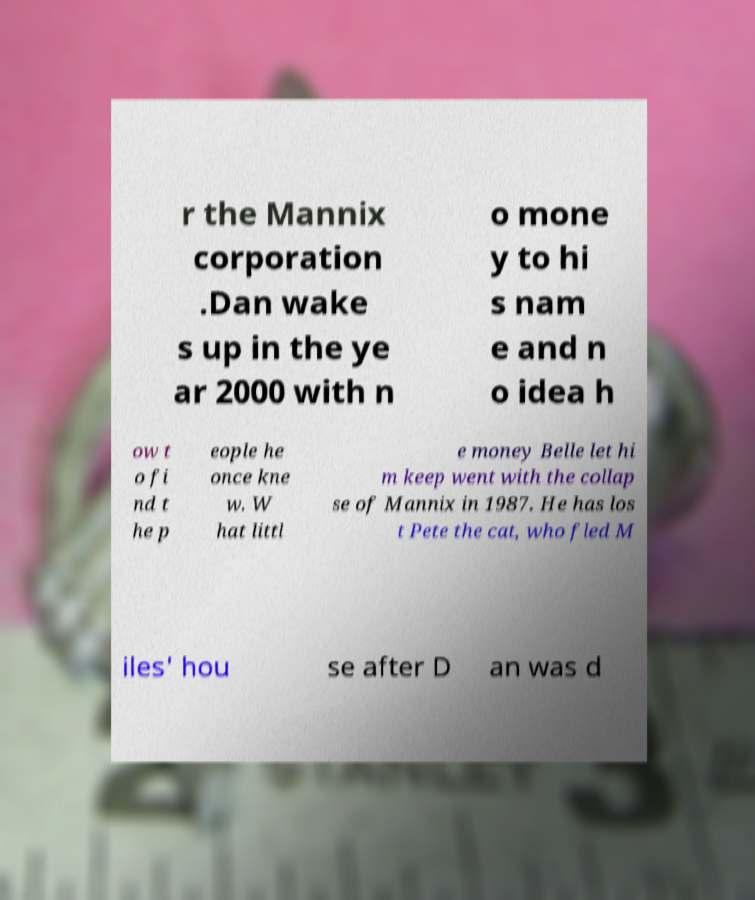Please identify and transcribe the text found in this image. r the Mannix corporation .Dan wake s up in the ye ar 2000 with n o mone y to hi s nam e and n o idea h ow t o fi nd t he p eople he once kne w. W hat littl e money Belle let hi m keep went with the collap se of Mannix in 1987. He has los t Pete the cat, who fled M iles' hou se after D an was d 